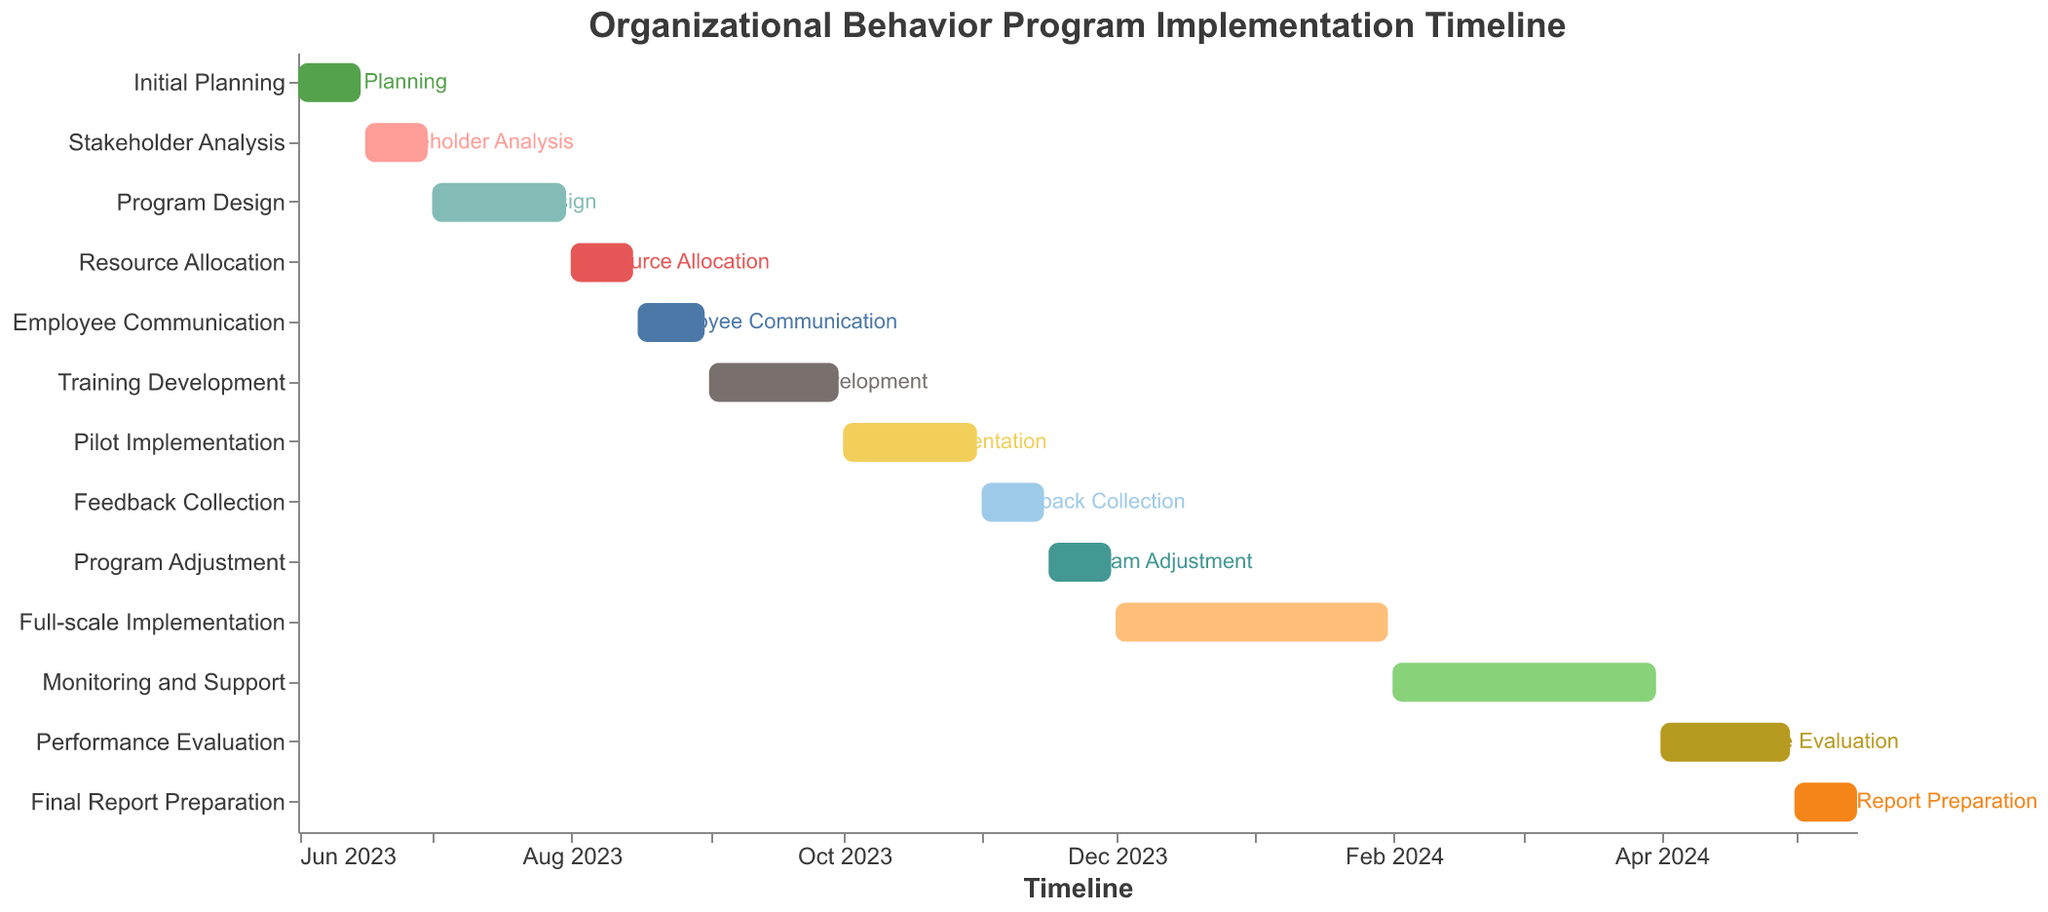What is the title of the Gantt Chart? The title is displayed at the top of the Gantt Chart and it describes the main subject of the chart. Here, it reads "Organizational Behavior Program Implementation Timeline".
Answer: Organizational Behavior Program Implementation Timeline How long does the "Initial Planning" stage last? To determine the duration of the "Initial Planning" stage, subtract the start date (June 1, 2023) from the end date (June 15, 2023). This results in 15 days.
Answer: 15 days Which stage has the shortest duration? To find the shortest stage, compare the durations of all stages. "Feedback Collection" and "Final Report Preparation" each last for 15 days.
Answer: Feedback Collection or Final Report Preparation How many months is the "Full-scale Implementation" scheduled for? The "Full-scale Implementation" stage starts on December 1, 2023, and ends on January 31, 2024. Counting December and January results in a total of 2 months.
Answer: 2 months Which stage immediately follows "Training Development"? By inspecting the sequence of tasks on the Y-axis, the stage that follows "Training Development" is "Pilot Implementation".
Answer: Pilot Implementation What is the longest stage in the implementation timeline? The longest stage can be identified by comparing the durations of all stages. "Full-scale Implementation" lasts from December 1, 2023, to January 31, 2024, which is the longest duration at 2 months.
Answer: Full-scale Implementation When does the "Monitoring and Support" stage end? The end date of "Monitoring and Support" is visually represented at the end of its corresponding bar, which is March 31, 2024.
Answer: March 31, 2024 What are the start and end dates for the "Program Design" stage? The start and end dates for the "Program Design" stage are listed directly in the Gantt Chart. The stage starts on July 1, 2023, and ends on July 31, 2023.
Answer: July 1, 2023, to July 31, 2023 How much time is spent on post-implementation activities (from "Feedback Collection" to "Final Report Preparation")? Sum the durations of the stages from "Feedback Collection" to "Final Report Preparation". "Feedback Collection" (15 days), "Program Adjustment" (15 days), "Full-scale Implementation" (2 months), "Monitoring and Support" (2 months), "Performance Evaluation" (1 month), and "Final Report Preparation" (15 days), which totals to approximately 5.5 months.
Answer: 5.5 months 